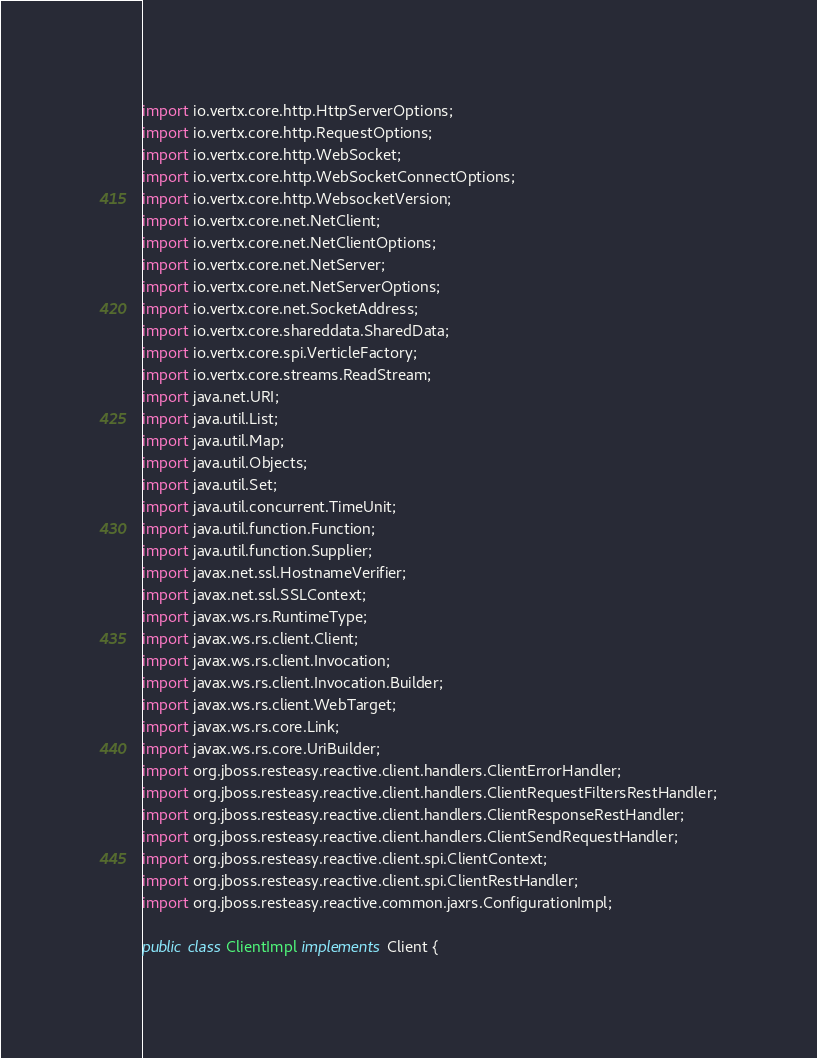Convert code to text. <code><loc_0><loc_0><loc_500><loc_500><_Java_>import io.vertx.core.http.HttpServerOptions;
import io.vertx.core.http.RequestOptions;
import io.vertx.core.http.WebSocket;
import io.vertx.core.http.WebSocketConnectOptions;
import io.vertx.core.http.WebsocketVersion;
import io.vertx.core.net.NetClient;
import io.vertx.core.net.NetClientOptions;
import io.vertx.core.net.NetServer;
import io.vertx.core.net.NetServerOptions;
import io.vertx.core.net.SocketAddress;
import io.vertx.core.shareddata.SharedData;
import io.vertx.core.spi.VerticleFactory;
import io.vertx.core.streams.ReadStream;
import java.net.URI;
import java.util.List;
import java.util.Map;
import java.util.Objects;
import java.util.Set;
import java.util.concurrent.TimeUnit;
import java.util.function.Function;
import java.util.function.Supplier;
import javax.net.ssl.HostnameVerifier;
import javax.net.ssl.SSLContext;
import javax.ws.rs.RuntimeType;
import javax.ws.rs.client.Client;
import javax.ws.rs.client.Invocation;
import javax.ws.rs.client.Invocation.Builder;
import javax.ws.rs.client.WebTarget;
import javax.ws.rs.core.Link;
import javax.ws.rs.core.UriBuilder;
import org.jboss.resteasy.reactive.client.handlers.ClientErrorHandler;
import org.jboss.resteasy.reactive.client.handlers.ClientRequestFiltersRestHandler;
import org.jboss.resteasy.reactive.client.handlers.ClientResponseRestHandler;
import org.jboss.resteasy.reactive.client.handlers.ClientSendRequestHandler;
import org.jboss.resteasy.reactive.client.spi.ClientContext;
import org.jboss.resteasy.reactive.client.spi.ClientRestHandler;
import org.jboss.resteasy.reactive.common.jaxrs.ConfigurationImpl;

public class ClientImpl implements Client {
</code> 